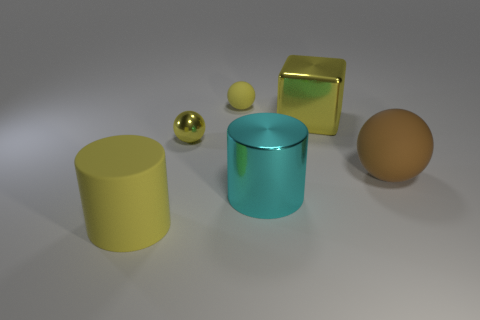What material is the large thing that is the same color as the large cube?
Your answer should be compact. Rubber. There is a metal thing in front of the big brown rubber object; is its shape the same as the big thing that is in front of the large metal cylinder?
Ensure brevity in your answer.  Yes. What is the material of the other cylinder that is the same size as the shiny cylinder?
Offer a very short reply. Rubber. Are the thing that is on the right side of the big block and the large cylinder that is on the right side of the small metal sphere made of the same material?
Provide a short and direct response. No. There is a cyan thing that is the same size as the brown thing; what is its shape?
Your answer should be very brief. Cylinder. What number of other objects are there of the same color as the tiny metal object?
Offer a very short reply. 3. The metallic thing that is right of the metallic cylinder is what color?
Give a very brief answer. Yellow. How many other things are the same material as the yellow cube?
Offer a very short reply. 2. Is the number of tiny matte balls left of the large yellow cylinder greater than the number of objects that are behind the tiny shiny ball?
Offer a very short reply. No. There is a large yellow rubber object; how many large matte objects are on the right side of it?
Offer a terse response. 1. 